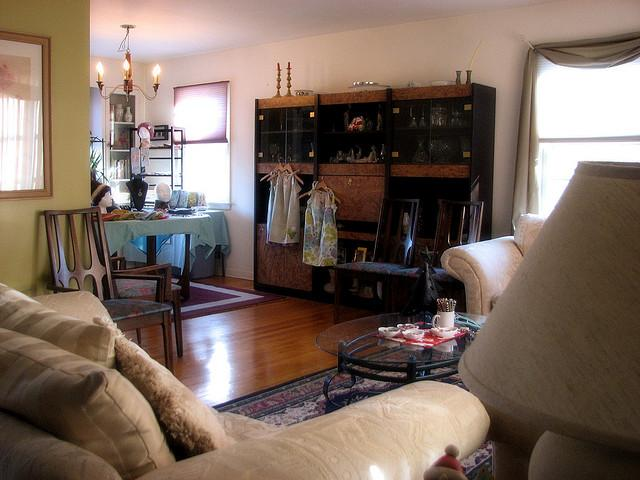Why are the clothes on hangers? drying 